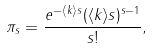<formula> <loc_0><loc_0><loc_500><loc_500>\pi _ { s } = \frac { e ^ { - \langle k \rangle s } ( \langle k \rangle s ) ^ { s - 1 } } { s ! } ,</formula> 